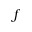Convert formula to latex. <formula><loc_0><loc_0><loc_500><loc_500>f</formula> 